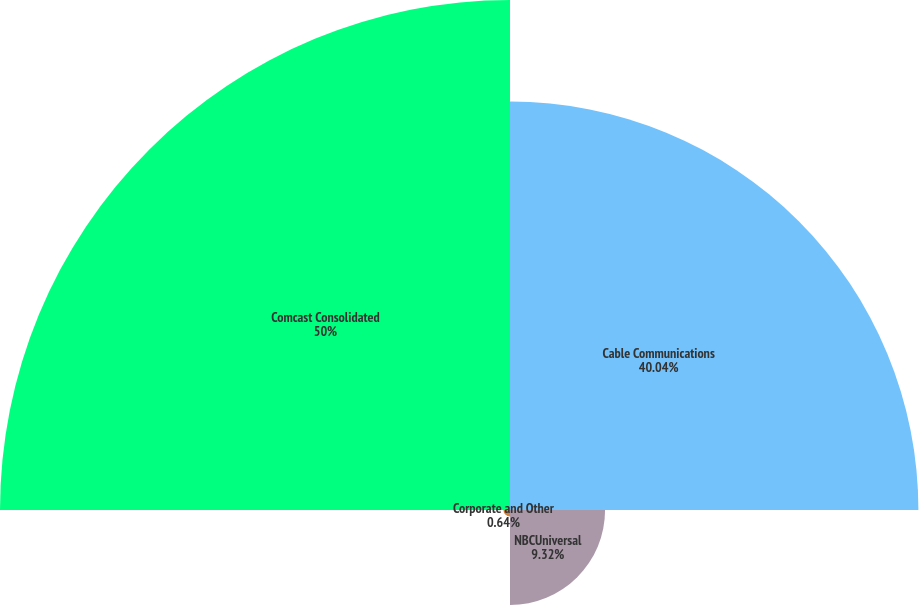<chart> <loc_0><loc_0><loc_500><loc_500><pie_chart><fcel>Cable Communications<fcel>NBCUniversal<fcel>Corporate and Other<fcel>Comcast Consolidated<nl><fcel>40.04%<fcel>9.32%<fcel>0.64%<fcel>50.0%<nl></chart> 